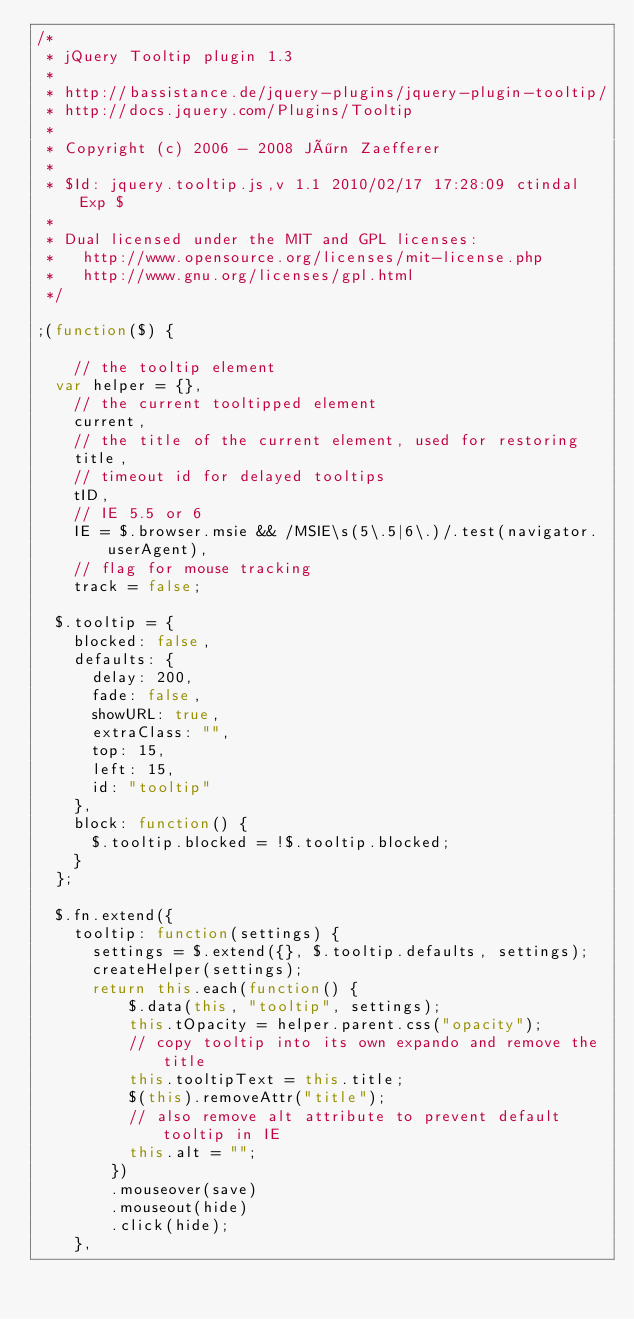<code> <loc_0><loc_0><loc_500><loc_500><_JavaScript_>/*
 * jQuery Tooltip plugin 1.3
 *
 * http://bassistance.de/jquery-plugins/jquery-plugin-tooltip/
 * http://docs.jquery.com/Plugins/Tooltip
 *
 * Copyright (c) 2006 - 2008 Jörn Zaefferer
 *
 * $Id: jquery.tooltip.js,v 1.1 2010/02/17 17:28:09 ctindal Exp $
 * 
 * Dual licensed under the MIT and GPL licenses:
 *   http://www.opensource.org/licenses/mit-license.php
 *   http://www.gnu.org/licenses/gpl.html
 */
 
;(function($) {
	
		// the tooltip element
	var helper = {},
		// the current tooltipped element
		current,
		// the title of the current element, used for restoring
		title,
		// timeout id for delayed tooltips
		tID,
		// IE 5.5 or 6
		IE = $.browser.msie && /MSIE\s(5\.5|6\.)/.test(navigator.userAgent),
		// flag for mouse tracking
		track = false;
	
	$.tooltip = {
		blocked: false,
		defaults: {
			delay: 200,
			fade: false,
			showURL: true,
			extraClass: "",
			top: 15,
			left: 15,
			id: "tooltip"
		},
		block: function() {
			$.tooltip.blocked = !$.tooltip.blocked;
		}
	};
	
	$.fn.extend({
		tooltip: function(settings) {
			settings = $.extend({}, $.tooltip.defaults, settings);
			createHelper(settings);
			return this.each(function() {
					$.data(this, "tooltip", settings);
					this.tOpacity = helper.parent.css("opacity");
					// copy tooltip into its own expando and remove the title
					this.tooltipText = this.title;
					$(this).removeAttr("title");
					// also remove alt attribute to prevent default tooltip in IE
					this.alt = "";
				})
				.mouseover(save)
				.mouseout(hide)
				.click(hide);
		},</code> 